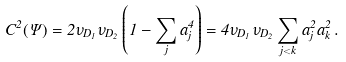<formula> <loc_0><loc_0><loc_500><loc_500>C ^ { 2 } ( \Psi ) = 2 \nu _ { D _ { 1 } } \nu _ { D _ { 2 } } \left ( 1 - \sum _ { j } a _ { j } ^ { 4 } \right ) = 4 \nu _ { D _ { 1 } } \nu _ { D _ { 2 } } \sum _ { j < k } a _ { j } ^ { 2 } a _ { k } ^ { 2 } \, .</formula> 